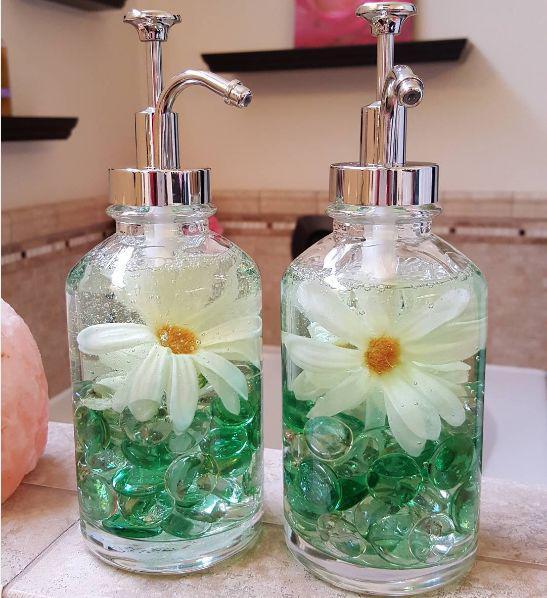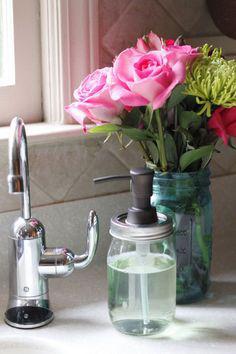The first image is the image on the left, the second image is the image on the right. Analyze the images presented: Is the assertion "The image on the right has pink flowers inside of a vase." valid? Answer yes or no. Yes. 